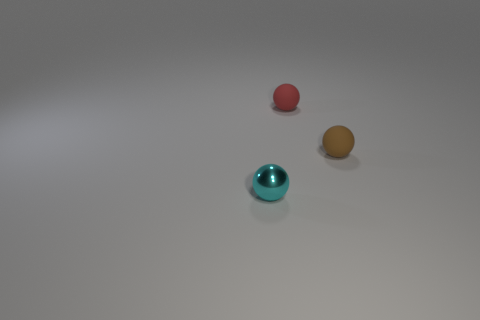Are there fewer tiny cyan shiny balls that are in front of the tiny cyan thing than small matte balls to the right of the red ball?
Offer a very short reply. Yes. Does the brown object have the same shape as the small shiny object?
Your response must be concise. Yes. What number of cyan things have the same size as the red rubber ball?
Your answer should be compact. 1. Are there fewer rubber spheres that are on the left side of the brown sphere than small red things?
Make the answer very short. No. There is a rubber thing on the left side of the matte thing that is in front of the red rubber object; how big is it?
Offer a very short reply. Small. How many objects are blocks or cyan things?
Your answer should be very brief. 1. Are there fewer cyan shiny balls than big cyan shiny cylinders?
Give a very brief answer. No. How many objects are tiny cyan shiny things or spheres that are on the right side of the small cyan thing?
Provide a succinct answer. 3. Is there a brown thing that has the same material as the red object?
Provide a short and direct response. Yes. There is a cyan thing that is the same size as the brown object; what is its material?
Your response must be concise. Metal. 